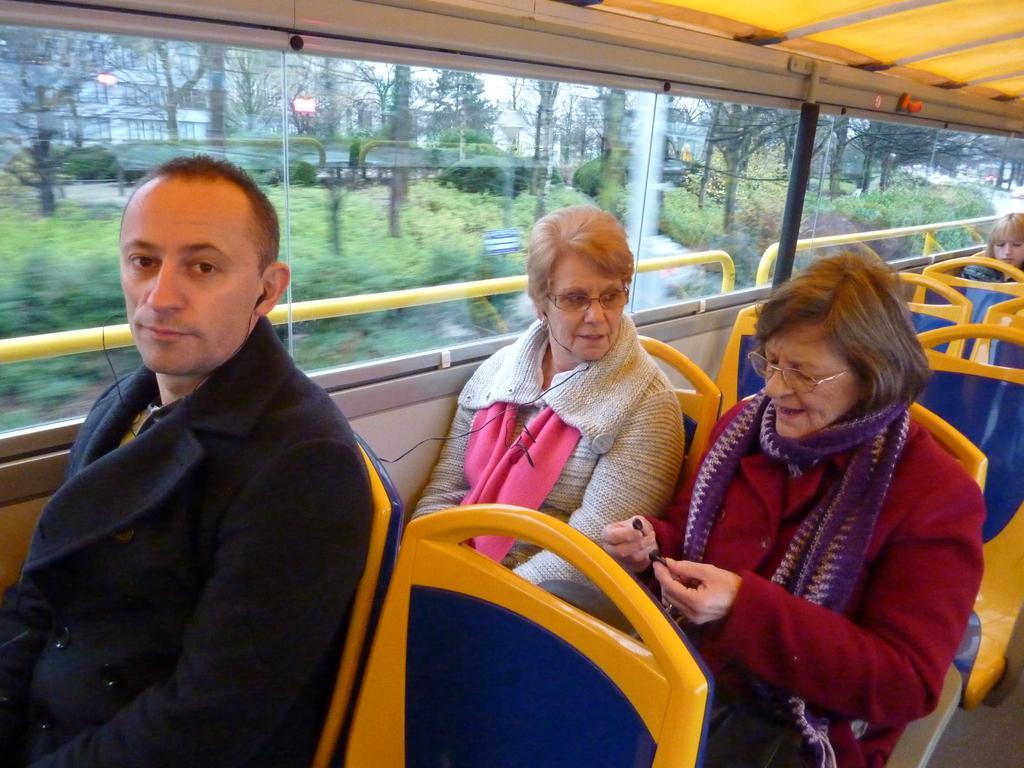Describe this image in one or two sentences. At the bottom of this image, there is a person and two women sitting on the chairs in a vehicle, which is having glass windows. In the background, there is a woman sitting on another chair. Through these glass windows, we can see there are trees, plants and buildings. 